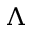Convert formula to latex. <formula><loc_0><loc_0><loc_500><loc_500>\Lambda</formula> 